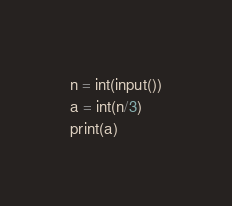Convert code to text. <code><loc_0><loc_0><loc_500><loc_500><_Python_>n = int(input())
a = int(n/3)
print(a)</code> 